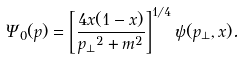<formula> <loc_0><loc_0><loc_500><loc_500>\Psi _ { 0 } ( { p } ) = \left [ \frac { 4 x ( 1 - x ) } { { p _ { \perp } } ^ { 2 } + m ^ { 2 } } \right ] ^ { 1 / 4 } \psi ( { p _ { \perp } } , x ) .</formula> 